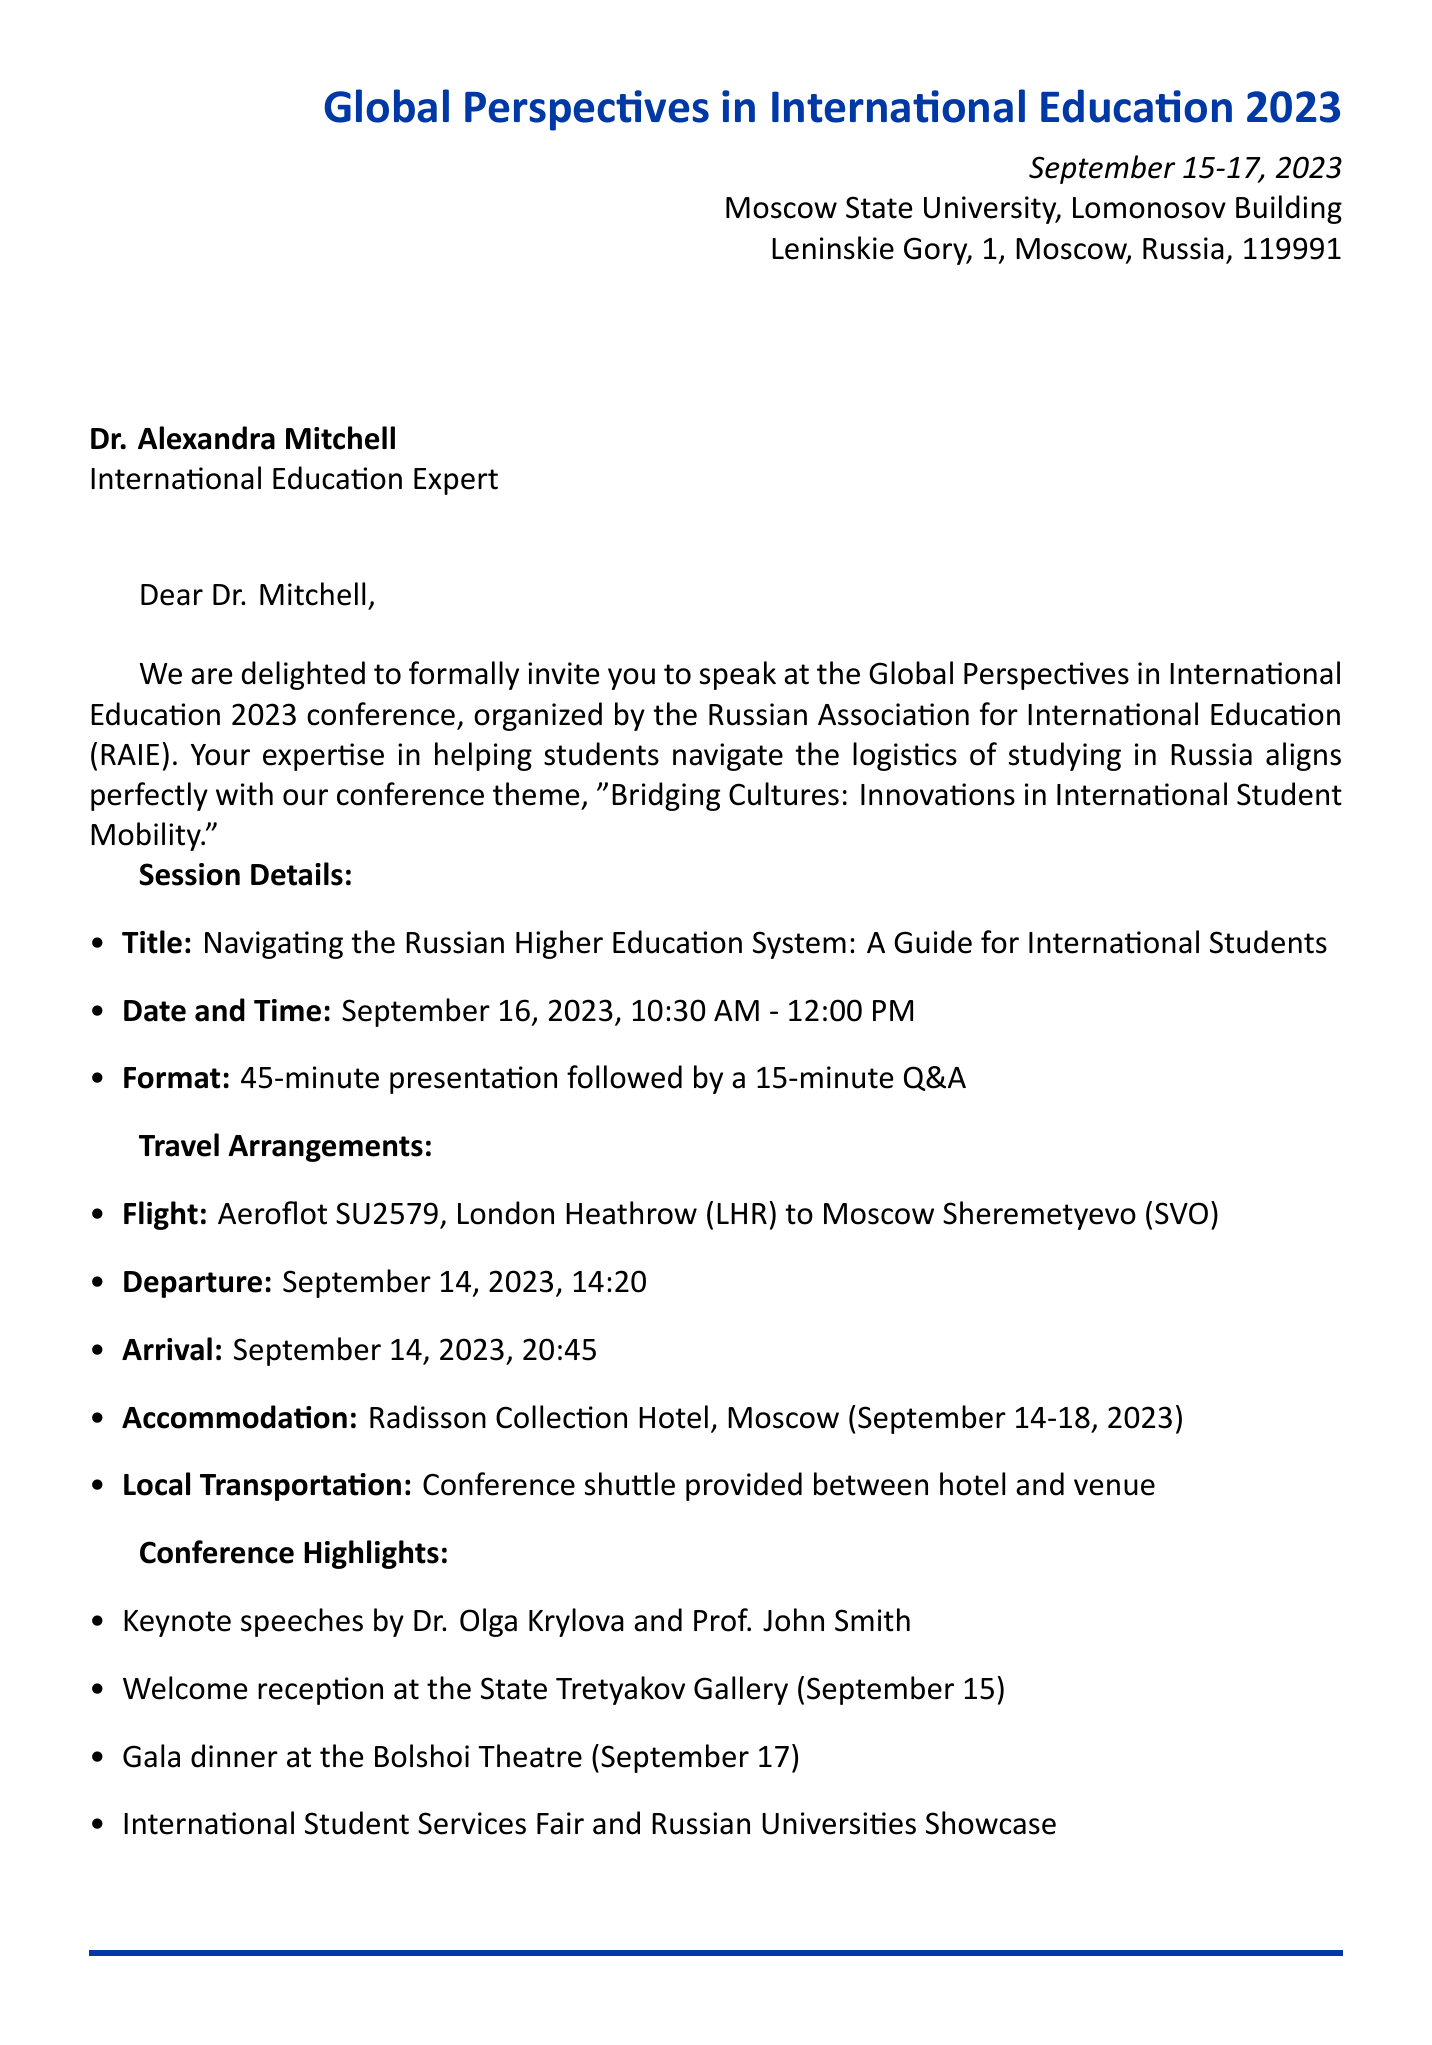What is the name of the conference? The document mentions the conference is named "Global Perspectives in International Education 2023."
Answer: Global Perspectives in International Education 2023 What are the dates of the conference? The dates of the conference are specified as September 15-17, 2023.
Answer: September 15-17, 2023 Who is the conference organizer? The document identifies the organizer of the conference as the Russian Association for International Education (RAIE).
Answer: Russian Association for International Education (RAIE) What is the session title for Dr. Mitchell's speech? The session title provided in the document for Dr. Mitchell's speech is "Navigating the Russian Higher Education System: A Guide for International Students."
Answer: Navigating the Russian Higher Education System: A Guide for International Students What time is Dr. Mitchell's session scheduled? The document specifies that Dr. Mitchell’s session is scheduled from 10:30 AM to 12:00 PM on September 16, 2023.
Answer: 10:30 AM - 12:00 PM What type of visa is required for the conference? The document states that a Business visa (humanitarian) is required for the conference.
Answer: Business visa (humanitarian) How many keynote speakers are mentioned? The document lists two keynote speakers, Dr. Olga Krylova and Prof. John Smith.
Answer: 2 When is the welcome reception scheduled? The welcome reception is scheduled for September 15, according to the document.
Answer: September 15 What hotel will accommodate Dr. Mitchell during the conference? The document indicates that Dr. Mitchell will stay at the Radisson Collection Hotel, Moscow.
Answer: Radisson Collection Hotel, Moscow 